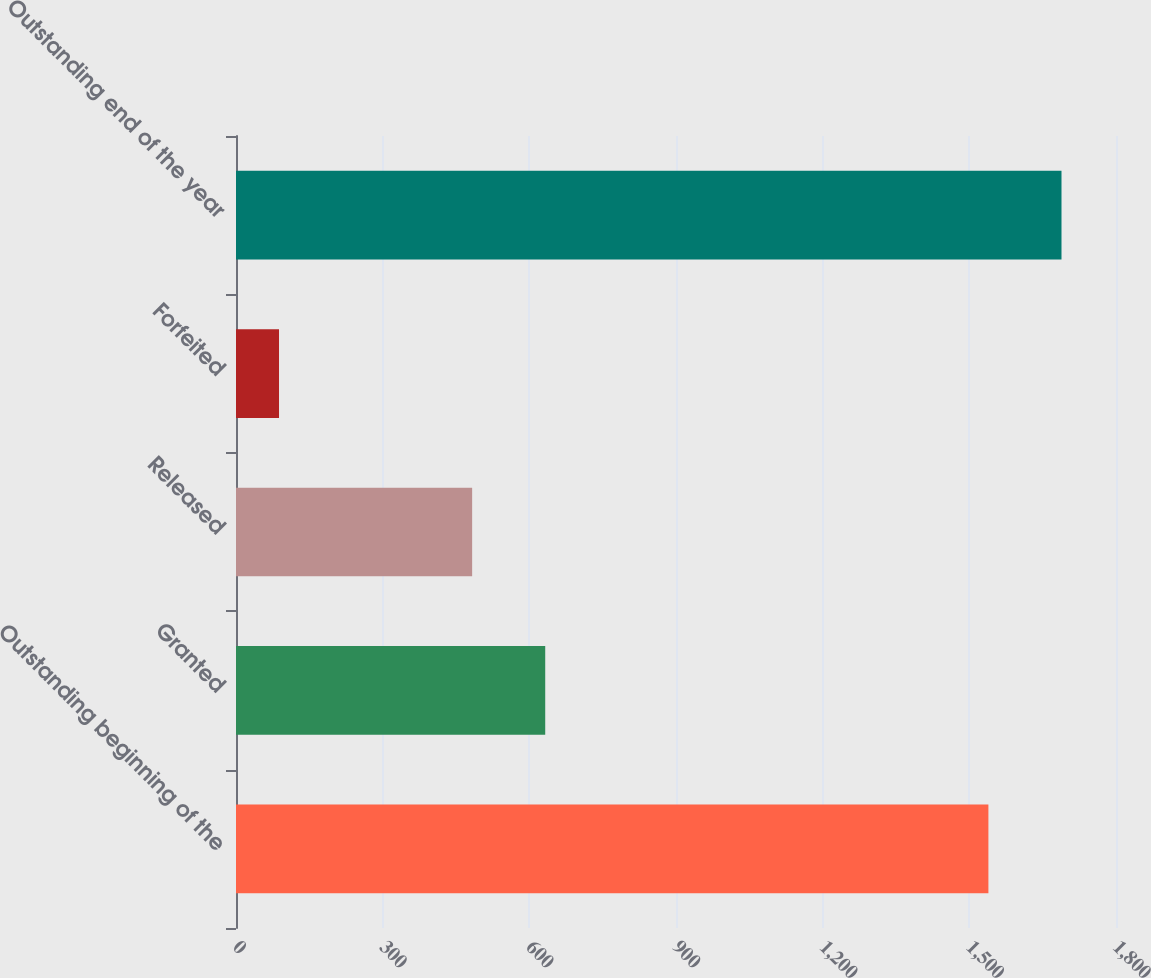Convert chart to OTSL. <chart><loc_0><loc_0><loc_500><loc_500><bar_chart><fcel>Outstanding beginning of the<fcel>Granted<fcel>Released<fcel>Forfeited<fcel>Outstanding end of the year<nl><fcel>1539<fcel>632.5<fcel>483<fcel>88<fcel>1688.5<nl></chart> 